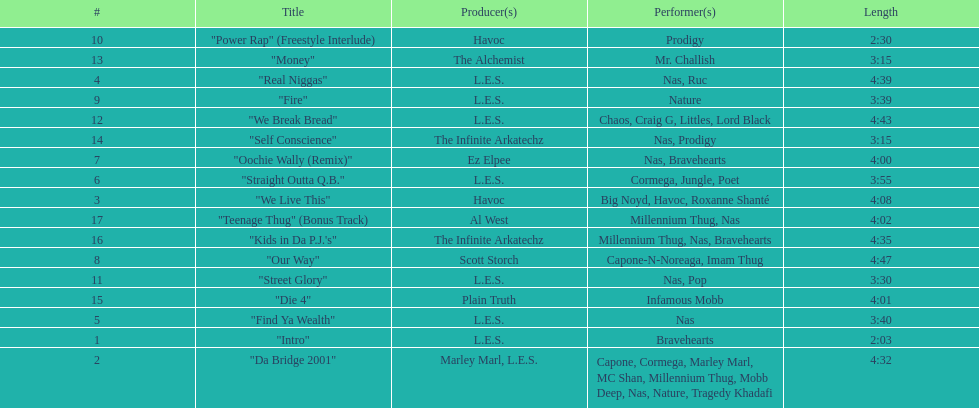How many songs are at least 4 minutes long? 9. 